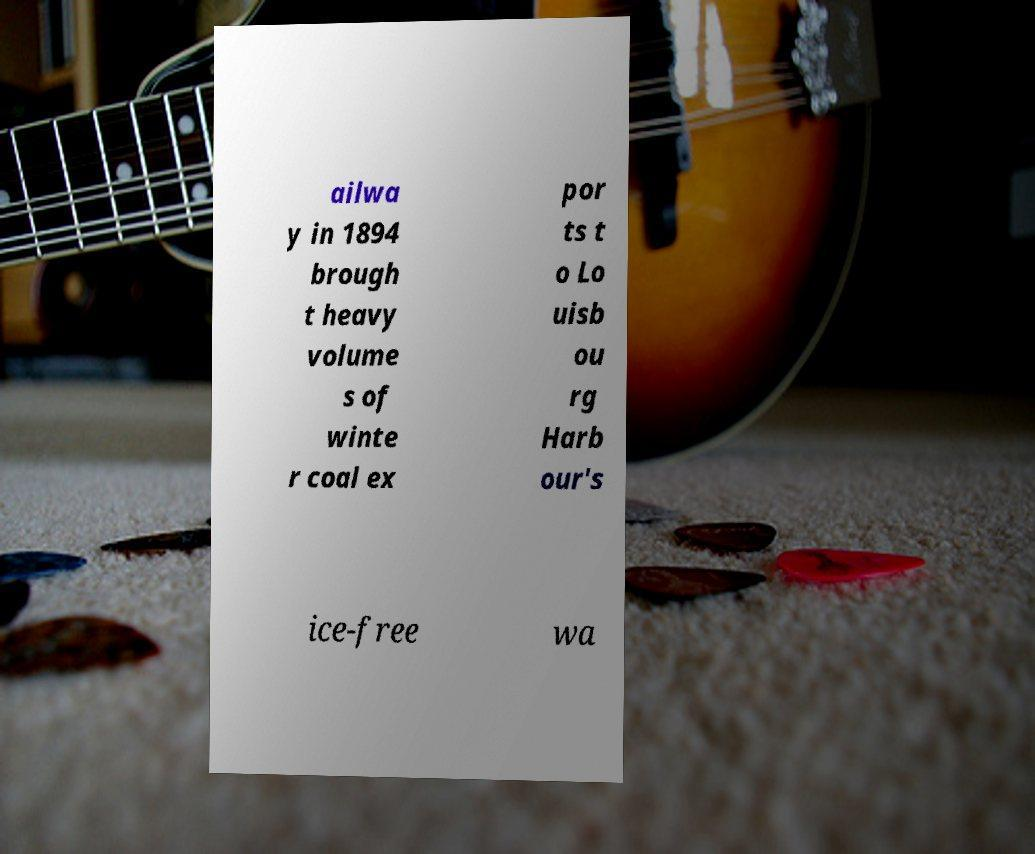For documentation purposes, I need the text within this image transcribed. Could you provide that? ailwa y in 1894 brough t heavy volume s of winte r coal ex por ts t o Lo uisb ou rg Harb our's ice-free wa 